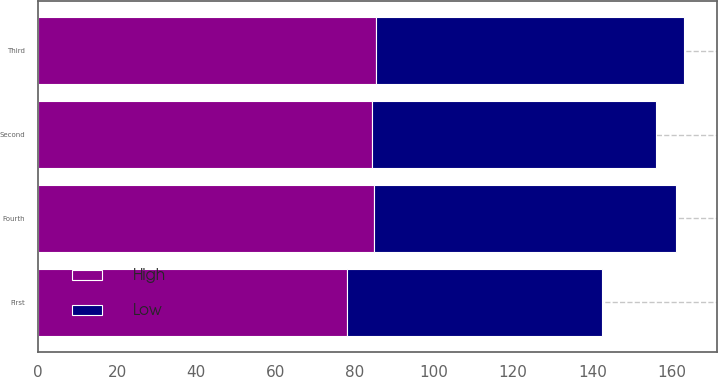Convert chart. <chart><loc_0><loc_0><loc_500><loc_500><stacked_bar_chart><ecel><fcel>First<fcel>Second<fcel>Third<fcel>Fourth<nl><fcel>High<fcel>78.12<fcel>84.27<fcel>85.41<fcel>84.89<nl><fcel>Low<fcel>64.43<fcel>71.87<fcel>77.8<fcel>76.26<nl></chart> 